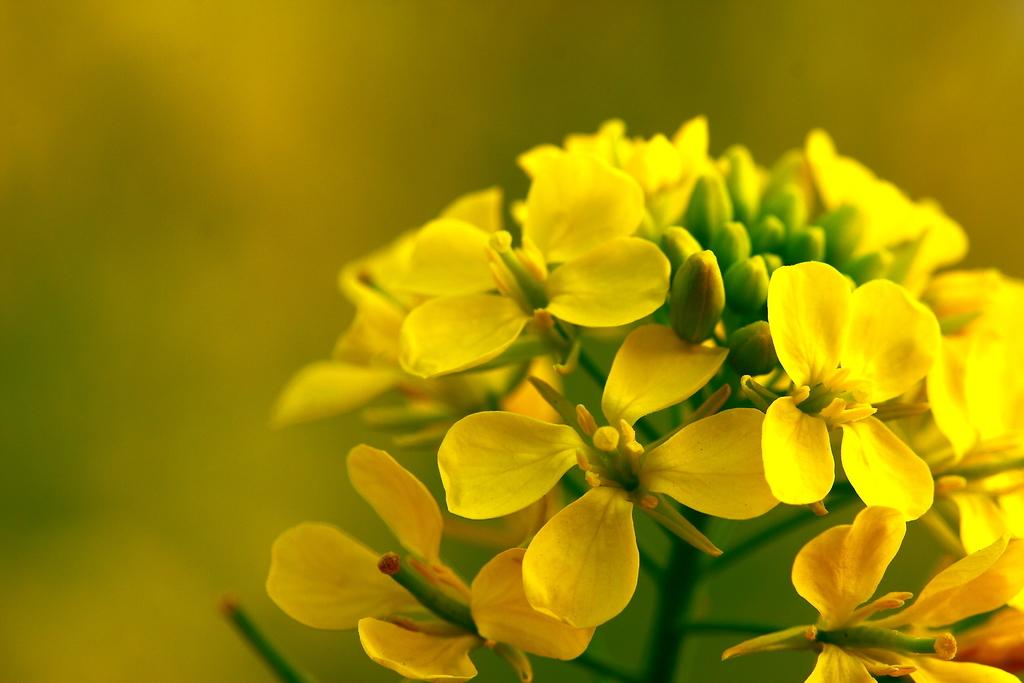What type of plants are in the image? There are flowers in the image. What color are the flowers? The flowers are yellow. What type of engine is powering the man's pet in the image? There is no engine, man, or pet present in the image; it only features yellow flowers. 